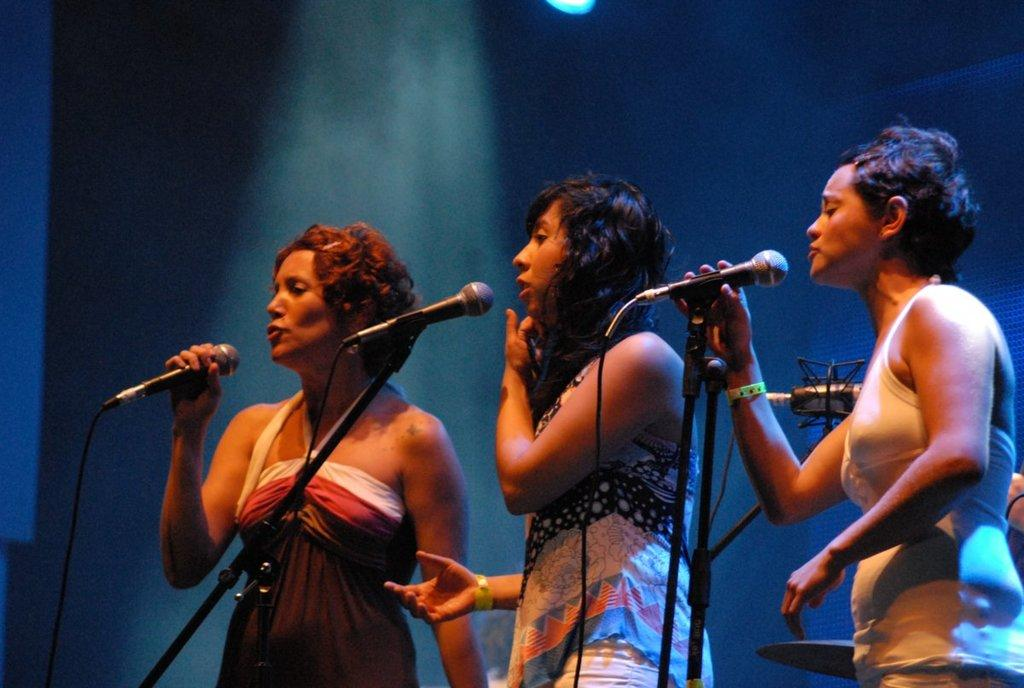How many people are in the image? There are three women in the image. What objects are in front of the women? There are microphones in front of the women. What direction is the stranger facing in the image? There is no stranger present in the image. 